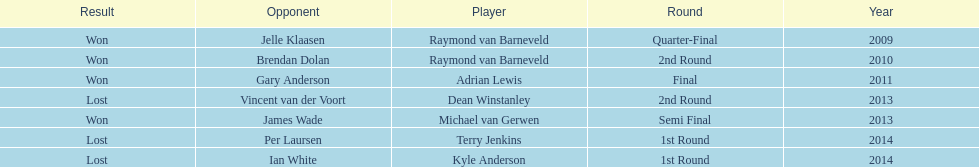Who won the first world darts championship? Raymond van Barneveld. 